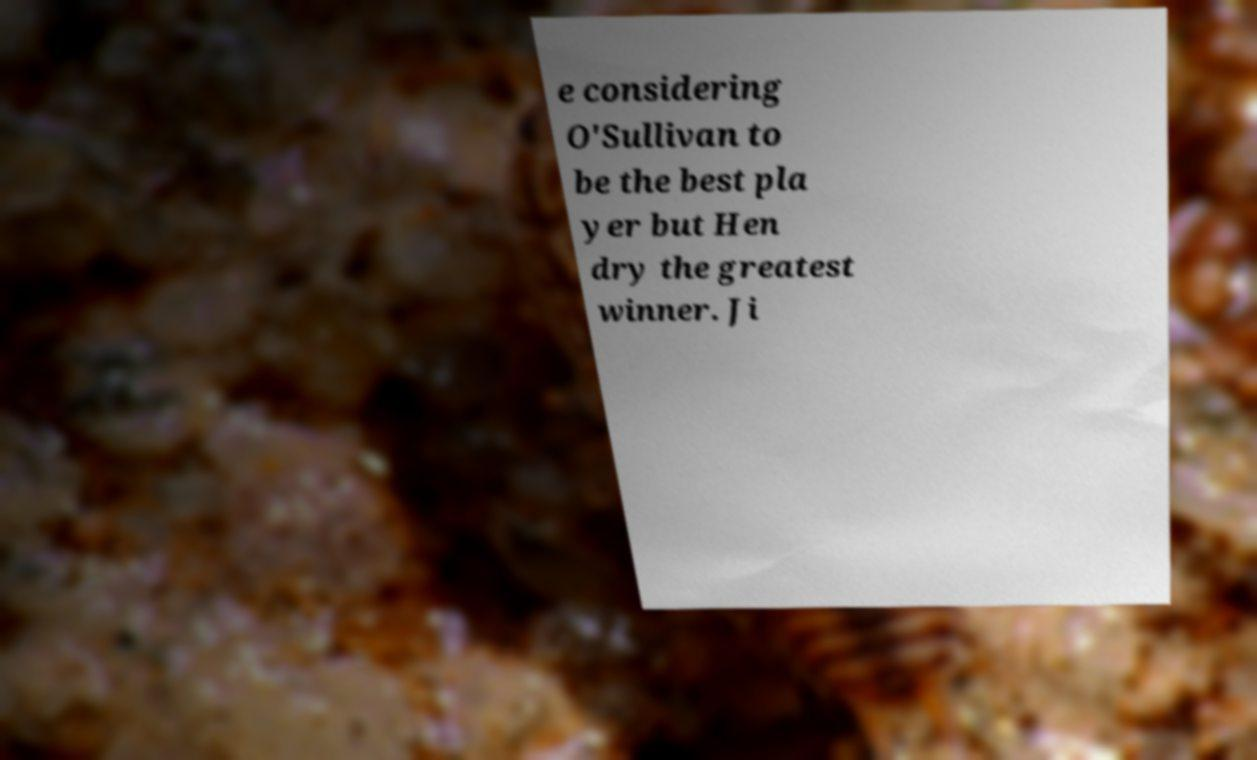I need the written content from this picture converted into text. Can you do that? e considering O'Sullivan to be the best pla yer but Hen dry the greatest winner. Ji 